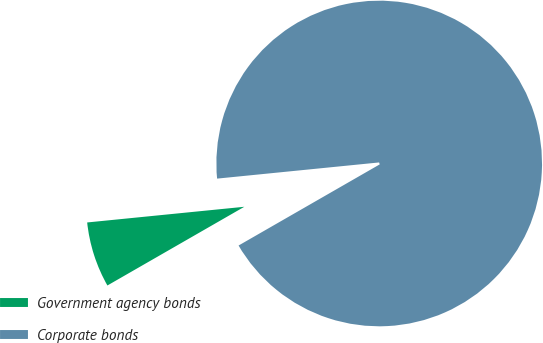Convert chart to OTSL. <chart><loc_0><loc_0><loc_500><loc_500><pie_chart><fcel>Government agency bonds<fcel>Corporate bonds<nl><fcel>6.72%<fcel>93.28%<nl></chart> 